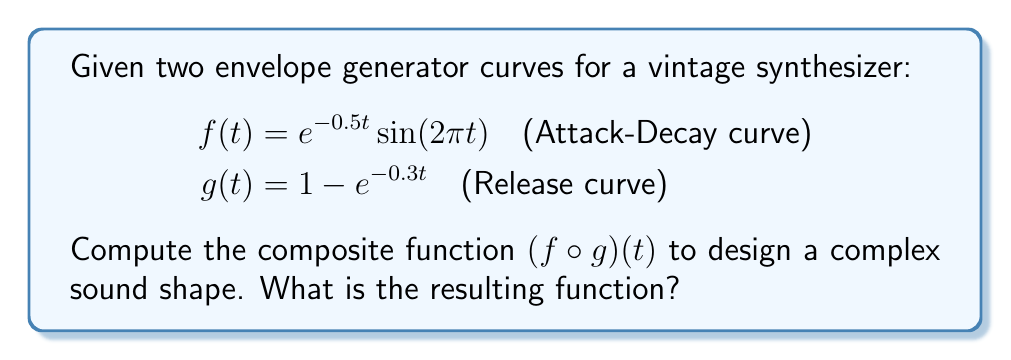Could you help me with this problem? To compute the composite function $(f \circ g)(t)$, we need to substitute $g(t)$ into $f(t)$ wherever $t$ appears in $f(t)$.

Step 1: Identify $g(t)$
$$g(t) = 1 - e^{-0.3t}$$

Step 2: Substitute $g(t)$ into $f(t)$
$$f(g(t)) = e^{-0.5(1 - e^{-0.3t})} \sin(2\pi(1 - e^{-0.3t}))$$

Step 3: Simplify the exponent in the first term
$$e^{-0.5 + 0.5e^{-0.3t}}$$

Step 4: The composite function $(f \circ g)(t)$ is therefore:
$$(f \circ g)(t) = e^{-0.5 + 0.5e^{-0.3t}} \sin(2\pi(1 - e^{-0.3t}))$$

This function combines the attack-decay characteristics of $f(t)$ with the release properties of $g(t)$, creating a more complex envelope for sound shaping in the vintage synthesizer.
Answer: $$(f \circ g)(t) = e^{-0.5 + 0.5e^{-0.3t}} \sin(2\pi(1 - e^{-0.3t}))$$ 